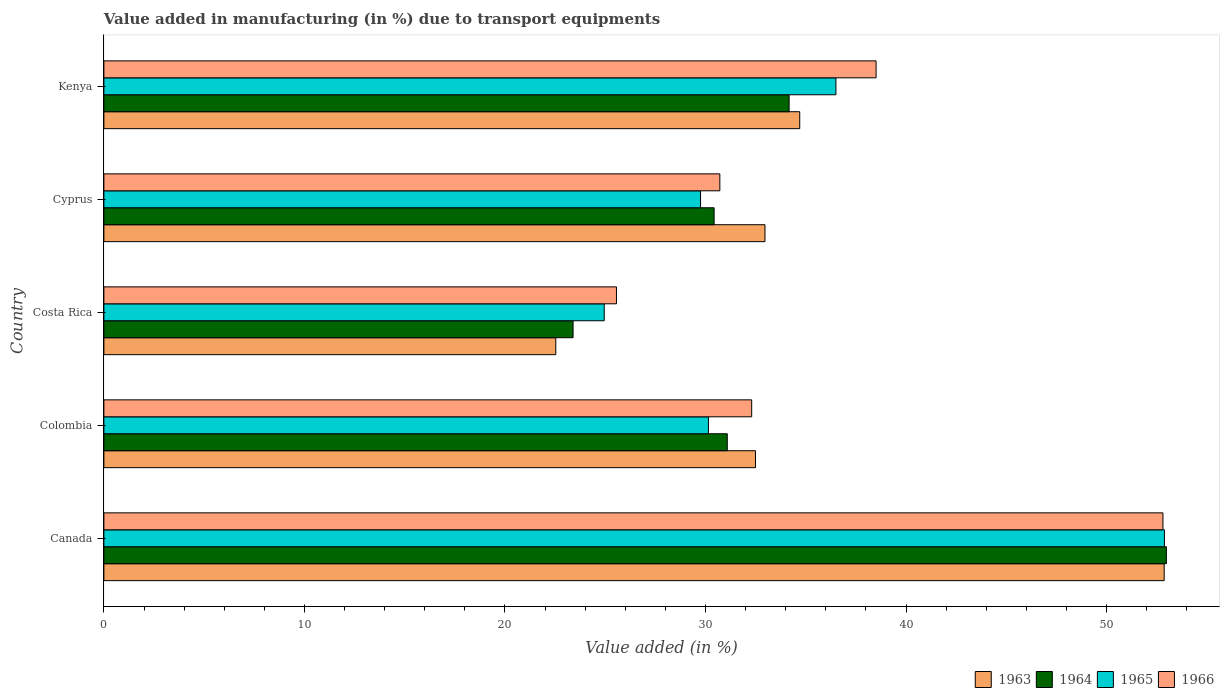How many groups of bars are there?
Your answer should be very brief. 5. What is the percentage of value added in manufacturing due to transport equipments in 1966 in Colombia?
Your response must be concise. 32.3. Across all countries, what is the maximum percentage of value added in manufacturing due to transport equipments in 1963?
Your answer should be compact. 52.87. Across all countries, what is the minimum percentage of value added in manufacturing due to transport equipments in 1963?
Give a very brief answer. 22.53. In which country was the percentage of value added in manufacturing due to transport equipments in 1964 minimum?
Your answer should be compact. Costa Rica. What is the total percentage of value added in manufacturing due to transport equipments in 1963 in the graph?
Provide a succinct answer. 175.57. What is the difference between the percentage of value added in manufacturing due to transport equipments in 1965 in Colombia and that in Cyprus?
Keep it short and to the point. 0.39. What is the difference between the percentage of value added in manufacturing due to transport equipments in 1963 in Cyprus and the percentage of value added in manufacturing due to transport equipments in 1965 in Costa Rica?
Make the answer very short. 8.02. What is the average percentage of value added in manufacturing due to transport equipments in 1966 per country?
Give a very brief answer. 35.98. What is the difference between the percentage of value added in manufacturing due to transport equipments in 1964 and percentage of value added in manufacturing due to transport equipments in 1965 in Costa Rica?
Ensure brevity in your answer.  -1.55. In how many countries, is the percentage of value added in manufacturing due to transport equipments in 1965 greater than 12 %?
Ensure brevity in your answer.  5. What is the ratio of the percentage of value added in manufacturing due to transport equipments in 1964 in Canada to that in Costa Rica?
Keep it short and to the point. 2.26. Is the percentage of value added in manufacturing due to transport equipments in 1966 in Canada less than that in Colombia?
Provide a short and direct response. No. Is the difference between the percentage of value added in manufacturing due to transport equipments in 1964 in Costa Rica and Kenya greater than the difference between the percentage of value added in manufacturing due to transport equipments in 1965 in Costa Rica and Kenya?
Your answer should be compact. Yes. What is the difference between the highest and the second highest percentage of value added in manufacturing due to transport equipments in 1966?
Ensure brevity in your answer.  14.3. What is the difference between the highest and the lowest percentage of value added in manufacturing due to transport equipments in 1966?
Ensure brevity in your answer.  27.25. Is it the case that in every country, the sum of the percentage of value added in manufacturing due to transport equipments in 1965 and percentage of value added in manufacturing due to transport equipments in 1964 is greater than the sum of percentage of value added in manufacturing due to transport equipments in 1966 and percentage of value added in manufacturing due to transport equipments in 1963?
Provide a succinct answer. No. Is it the case that in every country, the sum of the percentage of value added in manufacturing due to transport equipments in 1966 and percentage of value added in manufacturing due to transport equipments in 1965 is greater than the percentage of value added in manufacturing due to transport equipments in 1964?
Ensure brevity in your answer.  Yes. Are all the bars in the graph horizontal?
Ensure brevity in your answer.  Yes. What is the difference between two consecutive major ticks on the X-axis?
Provide a short and direct response. 10. Are the values on the major ticks of X-axis written in scientific E-notation?
Keep it short and to the point. No. Does the graph contain any zero values?
Offer a terse response. No. Where does the legend appear in the graph?
Provide a succinct answer. Bottom right. How many legend labels are there?
Make the answer very short. 4. How are the legend labels stacked?
Keep it short and to the point. Horizontal. What is the title of the graph?
Your answer should be compact. Value added in manufacturing (in %) due to transport equipments. Does "1987" appear as one of the legend labels in the graph?
Provide a short and direct response. No. What is the label or title of the X-axis?
Your answer should be very brief. Value added (in %). What is the label or title of the Y-axis?
Provide a short and direct response. Country. What is the Value added (in %) of 1963 in Canada?
Offer a very short reply. 52.87. What is the Value added (in %) in 1964 in Canada?
Provide a short and direct response. 52.98. What is the Value added (in %) of 1965 in Canada?
Make the answer very short. 52.89. What is the Value added (in %) in 1966 in Canada?
Your answer should be compact. 52.81. What is the Value added (in %) of 1963 in Colombia?
Offer a terse response. 32.49. What is the Value added (in %) in 1964 in Colombia?
Your answer should be very brief. 31.09. What is the Value added (in %) in 1965 in Colombia?
Your answer should be very brief. 30.15. What is the Value added (in %) in 1966 in Colombia?
Provide a short and direct response. 32.3. What is the Value added (in %) in 1963 in Costa Rica?
Give a very brief answer. 22.53. What is the Value added (in %) of 1964 in Costa Rica?
Offer a very short reply. 23.4. What is the Value added (in %) in 1965 in Costa Rica?
Your response must be concise. 24.95. What is the Value added (in %) of 1966 in Costa Rica?
Your answer should be very brief. 25.56. What is the Value added (in %) of 1963 in Cyprus?
Ensure brevity in your answer.  32.97. What is the Value added (in %) in 1964 in Cyprus?
Offer a very short reply. 30.43. What is the Value added (in %) in 1965 in Cyprus?
Offer a terse response. 29.75. What is the Value added (in %) in 1966 in Cyprus?
Your response must be concise. 30.72. What is the Value added (in %) of 1963 in Kenya?
Your answer should be very brief. 34.7. What is the Value added (in %) of 1964 in Kenya?
Your answer should be very brief. 34.17. What is the Value added (in %) in 1965 in Kenya?
Your answer should be very brief. 36.5. What is the Value added (in %) in 1966 in Kenya?
Your answer should be very brief. 38.51. Across all countries, what is the maximum Value added (in %) of 1963?
Offer a very short reply. 52.87. Across all countries, what is the maximum Value added (in %) in 1964?
Provide a short and direct response. 52.98. Across all countries, what is the maximum Value added (in %) in 1965?
Offer a very short reply. 52.89. Across all countries, what is the maximum Value added (in %) of 1966?
Ensure brevity in your answer.  52.81. Across all countries, what is the minimum Value added (in %) of 1963?
Make the answer very short. 22.53. Across all countries, what is the minimum Value added (in %) of 1964?
Offer a terse response. 23.4. Across all countries, what is the minimum Value added (in %) of 1965?
Offer a very short reply. 24.95. Across all countries, what is the minimum Value added (in %) in 1966?
Keep it short and to the point. 25.56. What is the total Value added (in %) of 1963 in the graph?
Ensure brevity in your answer.  175.57. What is the total Value added (in %) of 1964 in the graph?
Keep it short and to the point. 172.06. What is the total Value added (in %) in 1965 in the graph?
Offer a very short reply. 174.24. What is the total Value added (in %) in 1966 in the graph?
Ensure brevity in your answer.  179.9. What is the difference between the Value added (in %) of 1963 in Canada and that in Colombia?
Give a very brief answer. 20.38. What is the difference between the Value added (in %) in 1964 in Canada and that in Colombia?
Keep it short and to the point. 21.9. What is the difference between the Value added (in %) in 1965 in Canada and that in Colombia?
Your answer should be very brief. 22.74. What is the difference between the Value added (in %) of 1966 in Canada and that in Colombia?
Your response must be concise. 20.51. What is the difference between the Value added (in %) in 1963 in Canada and that in Costa Rica?
Keep it short and to the point. 30.34. What is the difference between the Value added (in %) in 1964 in Canada and that in Costa Rica?
Keep it short and to the point. 29.59. What is the difference between the Value added (in %) of 1965 in Canada and that in Costa Rica?
Provide a succinct answer. 27.93. What is the difference between the Value added (in %) of 1966 in Canada and that in Costa Rica?
Your answer should be compact. 27.25. What is the difference between the Value added (in %) of 1963 in Canada and that in Cyprus?
Offer a terse response. 19.91. What is the difference between the Value added (in %) in 1964 in Canada and that in Cyprus?
Offer a terse response. 22.55. What is the difference between the Value added (in %) in 1965 in Canada and that in Cyprus?
Keep it short and to the point. 23.13. What is the difference between the Value added (in %) in 1966 in Canada and that in Cyprus?
Provide a short and direct response. 22.1. What is the difference between the Value added (in %) in 1963 in Canada and that in Kenya?
Offer a terse response. 18.17. What is the difference between the Value added (in %) in 1964 in Canada and that in Kenya?
Give a very brief answer. 18.81. What is the difference between the Value added (in %) of 1965 in Canada and that in Kenya?
Keep it short and to the point. 16.38. What is the difference between the Value added (in %) of 1966 in Canada and that in Kenya?
Ensure brevity in your answer.  14.3. What is the difference between the Value added (in %) in 1963 in Colombia and that in Costa Rica?
Make the answer very short. 9.96. What is the difference between the Value added (in %) in 1964 in Colombia and that in Costa Rica?
Keep it short and to the point. 7.69. What is the difference between the Value added (in %) in 1965 in Colombia and that in Costa Rica?
Your answer should be compact. 5.2. What is the difference between the Value added (in %) in 1966 in Colombia and that in Costa Rica?
Your answer should be compact. 6.74. What is the difference between the Value added (in %) in 1963 in Colombia and that in Cyprus?
Provide a short and direct response. -0.47. What is the difference between the Value added (in %) in 1964 in Colombia and that in Cyprus?
Ensure brevity in your answer.  0.66. What is the difference between the Value added (in %) of 1965 in Colombia and that in Cyprus?
Your answer should be compact. 0.39. What is the difference between the Value added (in %) in 1966 in Colombia and that in Cyprus?
Ensure brevity in your answer.  1.59. What is the difference between the Value added (in %) of 1963 in Colombia and that in Kenya?
Make the answer very short. -2.21. What is the difference between the Value added (in %) of 1964 in Colombia and that in Kenya?
Your answer should be very brief. -3.08. What is the difference between the Value added (in %) of 1965 in Colombia and that in Kenya?
Make the answer very short. -6.36. What is the difference between the Value added (in %) in 1966 in Colombia and that in Kenya?
Provide a short and direct response. -6.2. What is the difference between the Value added (in %) in 1963 in Costa Rica and that in Cyprus?
Your answer should be compact. -10.43. What is the difference between the Value added (in %) in 1964 in Costa Rica and that in Cyprus?
Your answer should be compact. -7.03. What is the difference between the Value added (in %) of 1965 in Costa Rica and that in Cyprus?
Your answer should be very brief. -4.8. What is the difference between the Value added (in %) in 1966 in Costa Rica and that in Cyprus?
Give a very brief answer. -5.16. What is the difference between the Value added (in %) in 1963 in Costa Rica and that in Kenya?
Ensure brevity in your answer.  -12.17. What is the difference between the Value added (in %) in 1964 in Costa Rica and that in Kenya?
Provide a succinct answer. -10.77. What is the difference between the Value added (in %) of 1965 in Costa Rica and that in Kenya?
Make the answer very short. -11.55. What is the difference between the Value added (in %) in 1966 in Costa Rica and that in Kenya?
Keep it short and to the point. -12.95. What is the difference between the Value added (in %) in 1963 in Cyprus and that in Kenya?
Offer a very short reply. -1.73. What is the difference between the Value added (in %) in 1964 in Cyprus and that in Kenya?
Keep it short and to the point. -3.74. What is the difference between the Value added (in %) of 1965 in Cyprus and that in Kenya?
Your answer should be compact. -6.75. What is the difference between the Value added (in %) in 1966 in Cyprus and that in Kenya?
Give a very brief answer. -7.79. What is the difference between the Value added (in %) of 1963 in Canada and the Value added (in %) of 1964 in Colombia?
Offer a very short reply. 21.79. What is the difference between the Value added (in %) in 1963 in Canada and the Value added (in %) in 1965 in Colombia?
Offer a terse response. 22.73. What is the difference between the Value added (in %) of 1963 in Canada and the Value added (in %) of 1966 in Colombia?
Offer a terse response. 20.57. What is the difference between the Value added (in %) of 1964 in Canada and the Value added (in %) of 1965 in Colombia?
Make the answer very short. 22.84. What is the difference between the Value added (in %) of 1964 in Canada and the Value added (in %) of 1966 in Colombia?
Provide a succinct answer. 20.68. What is the difference between the Value added (in %) of 1965 in Canada and the Value added (in %) of 1966 in Colombia?
Your answer should be very brief. 20.58. What is the difference between the Value added (in %) of 1963 in Canada and the Value added (in %) of 1964 in Costa Rica?
Your answer should be very brief. 29.48. What is the difference between the Value added (in %) of 1963 in Canada and the Value added (in %) of 1965 in Costa Rica?
Your answer should be very brief. 27.92. What is the difference between the Value added (in %) of 1963 in Canada and the Value added (in %) of 1966 in Costa Rica?
Keep it short and to the point. 27.31. What is the difference between the Value added (in %) of 1964 in Canada and the Value added (in %) of 1965 in Costa Rica?
Provide a succinct answer. 28.03. What is the difference between the Value added (in %) in 1964 in Canada and the Value added (in %) in 1966 in Costa Rica?
Make the answer very short. 27.42. What is the difference between the Value added (in %) of 1965 in Canada and the Value added (in %) of 1966 in Costa Rica?
Provide a succinct answer. 27.33. What is the difference between the Value added (in %) in 1963 in Canada and the Value added (in %) in 1964 in Cyprus?
Give a very brief answer. 22.44. What is the difference between the Value added (in %) of 1963 in Canada and the Value added (in %) of 1965 in Cyprus?
Your response must be concise. 23.12. What is the difference between the Value added (in %) of 1963 in Canada and the Value added (in %) of 1966 in Cyprus?
Your answer should be compact. 22.16. What is the difference between the Value added (in %) in 1964 in Canada and the Value added (in %) in 1965 in Cyprus?
Your answer should be compact. 23.23. What is the difference between the Value added (in %) in 1964 in Canada and the Value added (in %) in 1966 in Cyprus?
Your answer should be very brief. 22.27. What is the difference between the Value added (in %) of 1965 in Canada and the Value added (in %) of 1966 in Cyprus?
Your answer should be very brief. 22.17. What is the difference between the Value added (in %) in 1963 in Canada and the Value added (in %) in 1964 in Kenya?
Provide a succinct answer. 18.7. What is the difference between the Value added (in %) in 1963 in Canada and the Value added (in %) in 1965 in Kenya?
Keep it short and to the point. 16.37. What is the difference between the Value added (in %) of 1963 in Canada and the Value added (in %) of 1966 in Kenya?
Give a very brief answer. 14.37. What is the difference between the Value added (in %) of 1964 in Canada and the Value added (in %) of 1965 in Kenya?
Offer a very short reply. 16.48. What is the difference between the Value added (in %) in 1964 in Canada and the Value added (in %) in 1966 in Kenya?
Give a very brief answer. 14.47. What is the difference between the Value added (in %) of 1965 in Canada and the Value added (in %) of 1966 in Kenya?
Ensure brevity in your answer.  14.38. What is the difference between the Value added (in %) in 1963 in Colombia and the Value added (in %) in 1964 in Costa Rica?
Keep it short and to the point. 9.1. What is the difference between the Value added (in %) in 1963 in Colombia and the Value added (in %) in 1965 in Costa Rica?
Make the answer very short. 7.54. What is the difference between the Value added (in %) of 1963 in Colombia and the Value added (in %) of 1966 in Costa Rica?
Your answer should be very brief. 6.93. What is the difference between the Value added (in %) in 1964 in Colombia and the Value added (in %) in 1965 in Costa Rica?
Offer a very short reply. 6.14. What is the difference between the Value added (in %) in 1964 in Colombia and the Value added (in %) in 1966 in Costa Rica?
Your response must be concise. 5.53. What is the difference between the Value added (in %) of 1965 in Colombia and the Value added (in %) of 1966 in Costa Rica?
Make the answer very short. 4.59. What is the difference between the Value added (in %) of 1963 in Colombia and the Value added (in %) of 1964 in Cyprus?
Make the answer very short. 2.06. What is the difference between the Value added (in %) of 1963 in Colombia and the Value added (in %) of 1965 in Cyprus?
Offer a very short reply. 2.74. What is the difference between the Value added (in %) of 1963 in Colombia and the Value added (in %) of 1966 in Cyprus?
Provide a short and direct response. 1.78. What is the difference between the Value added (in %) of 1964 in Colombia and the Value added (in %) of 1965 in Cyprus?
Keep it short and to the point. 1.33. What is the difference between the Value added (in %) of 1964 in Colombia and the Value added (in %) of 1966 in Cyprus?
Your answer should be compact. 0.37. What is the difference between the Value added (in %) in 1965 in Colombia and the Value added (in %) in 1966 in Cyprus?
Provide a succinct answer. -0.57. What is the difference between the Value added (in %) in 1963 in Colombia and the Value added (in %) in 1964 in Kenya?
Your answer should be very brief. -1.68. What is the difference between the Value added (in %) of 1963 in Colombia and the Value added (in %) of 1965 in Kenya?
Offer a very short reply. -4.01. What is the difference between the Value added (in %) in 1963 in Colombia and the Value added (in %) in 1966 in Kenya?
Make the answer very short. -6.01. What is the difference between the Value added (in %) of 1964 in Colombia and the Value added (in %) of 1965 in Kenya?
Offer a very short reply. -5.42. What is the difference between the Value added (in %) in 1964 in Colombia and the Value added (in %) in 1966 in Kenya?
Keep it short and to the point. -7.42. What is the difference between the Value added (in %) of 1965 in Colombia and the Value added (in %) of 1966 in Kenya?
Provide a succinct answer. -8.36. What is the difference between the Value added (in %) in 1963 in Costa Rica and the Value added (in %) in 1964 in Cyprus?
Provide a short and direct response. -7.9. What is the difference between the Value added (in %) of 1963 in Costa Rica and the Value added (in %) of 1965 in Cyprus?
Give a very brief answer. -7.22. What is the difference between the Value added (in %) of 1963 in Costa Rica and the Value added (in %) of 1966 in Cyprus?
Provide a short and direct response. -8.18. What is the difference between the Value added (in %) in 1964 in Costa Rica and the Value added (in %) in 1965 in Cyprus?
Keep it short and to the point. -6.36. What is the difference between the Value added (in %) in 1964 in Costa Rica and the Value added (in %) in 1966 in Cyprus?
Keep it short and to the point. -7.32. What is the difference between the Value added (in %) of 1965 in Costa Rica and the Value added (in %) of 1966 in Cyprus?
Your answer should be compact. -5.77. What is the difference between the Value added (in %) in 1963 in Costa Rica and the Value added (in %) in 1964 in Kenya?
Provide a succinct answer. -11.64. What is the difference between the Value added (in %) in 1963 in Costa Rica and the Value added (in %) in 1965 in Kenya?
Make the answer very short. -13.97. What is the difference between the Value added (in %) in 1963 in Costa Rica and the Value added (in %) in 1966 in Kenya?
Give a very brief answer. -15.97. What is the difference between the Value added (in %) of 1964 in Costa Rica and the Value added (in %) of 1965 in Kenya?
Your response must be concise. -13.11. What is the difference between the Value added (in %) of 1964 in Costa Rica and the Value added (in %) of 1966 in Kenya?
Provide a succinct answer. -15.11. What is the difference between the Value added (in %) of 1965 in Costa Rica and the Value added (in %) of 1966 in Kenya?
Your answer should be compact. -13.56. What is the difference between the Value added (in %) of 1963 in Cyprus and the Value added (in %) of 1964 in Kenya?
Offer a very short reply. -1.2. What is the difference between the Value added (in %) of 1963 in Cyprus and the Value added (in %) of 1965 in Kenya?
Make the answer very short. -3.54. What is the difference between the Value added (in %) in 1963 in Cyprus and the Value added (in %) in 1966 in Kenya?
Ensure brevity in your answer.  -5.54. What is the difference between the Value added (in %) of 1964 in Cyprus and the Value added (in %) of 1965 in Kenya?
Your answer should be compact. -6.07. What is the difference between the Value added (in %) of 1964 in Cyprus and the Value added (in %) of 1966 in Kenya?
Keep it short and to the point. -8.08. What is the difference between the Value added (in %) in 1965 in Cyprus and the Value added (in %) in 1966 in Kenya?
Keep it short and to the point. -8.75. What is the average Value added (in %) in 1963 per country?
Your response must be concise. 35.11. What is the average Value added (in %) of 1964 per country?
Give a very brief answer. 34.41. What is the average Value added (in %) in 1965 per country?
Offer a very short reply. 34.85. What is the average Value added (in %) of 1966 per country?
Your answer should be very brief. 35.98. What is the difference between the Value added (in %) of 1963 and Value added (in %) of 1964 in Canada?
Make the answer very short. -0.11. What is the difference between the Value added (in %) of 1963 and Value added (in %) of 1965 in Canada?
Give a very brief answer. -0.01. What is the difference between the Value added (in %) of 1963 and Value added (in %) of 1966 in Canada?
Give a very brief answer. 0.06. What is the difference between the Value added (in %) of 1964 and Value added (in %) of 1965 in Canada?
Your answer should be very brief. 0.1. What is the difference between the Value added (in %) of 1964 and Value added (in %) of 1966 in Canada?
Make the answer very short. 0.17. What is the difference between the Value added (in %) of 1965 and Value added (in %) of 1966 in Canada?
Your answer should be very brief. 0.07. What is the difference between the Value added (in %) in 1963 and Value added (in %) in 1964 in Colombia?
Provide a short and direct response. 1.41. What is the difference between the Value added (in %) in 1963 and Value added (in %) in 1965 in Colombia?
Offer a very short reply. 2.35. What is the difference between the Value added (in %) of 1963 and Value added (in %) of 1966 in Colombia?
Offer a very short reply. 0.19. What is the difference between the Value added (in %) of 1964 and Value added (in %) of 1965 in Colombia?
Offer a terse response. 0.94. What is the difference between the Value added (in %) of 1964 and Value added (in %) of 1966 in Colombia?
Offer a very short reply. -1.22. What is the difference between the Value added (in %) in 1965 and Value added (in %) in 1966 in Colombia?
Provide a succinct answer. -2.16. What is the difference between the Value added (in %) of 1963 and Value added (in %) of 1964 in Costa Rica?
Offer a very short reply. -0.86. What is the difference between the Value added (in %) of 1963 and Value added (in %) of 1965 in Costa Rica?
Offer a terse response. -2.42. What is the difference between the Value added (in %) in 1963 and Value added (in %) in 1966 in Costa Rica?
Your answer should be compact. -3.03. What is the difference between the Value added (in %) of 1964 and Value added (in %) of 1965 in Costa Rica?
Your answer should be very brief. -1.55. What is the difference between the Value added (in %) of 1964 and Value added (in %) of 1966 in Costa Rica?
Your answer should be very brief. -2.16. What is the difference between the Value added (in %) of 1965 and Value added (in %) of 1966 in Costa Rica?
Offer a very short reply. -0.61. What is the difference between the Value added (in %) of 1963 and Value added (in %) of 1964 in Cyprus?
Keep it short and to the point. 2.54. What is the difference between the Value added (in %) of 1963 and Value added (in %) of 1965 in Cyprus?
Your response must be concise. 3.21. What is the difference between the Value added (in %) of 1963 and Value added (in %) of 1966 in Cyprus?
Make the answer very short. 2.25. What is the difference between the Value added (in %) in 1964 and Value added (in %) in 1965 in Cyprus?
Give a very brief answer. 0.68. What is the difference between the Value added (in %) in 1964 and Value added (in %) in 1966 in Cyprus?
Your answer should be very brief. -0.29. What is the difference between the Value added (in %) of 1965 and Value added (in %) of 1966 in Cyprus?
Your answer should be very brief. -0.96. What is the difference between the Value added (in %) in 1963 and Value added (in %) in 1964 in Kenya?
Provide a succinct answer. 0.53. What is the difference between the Value added (in %) in 1963 and Value added (in %) in 1965 in Kenya?
Your response must be concise. -1.8. What is the difference between the Value added (in %) of 1963 and Value added (in %) of 1966 in Kenya?
Your answer should be compact. -3.81. What is the difference between the Value added (in %) of 1964 and Value added (in %) of 1965 in Kenya?
Give a very brief answer. -2.33. What is the difference between the Value added (in %) of 1964 and Value added (in %) of 1966 in Kenya?
Provide a succinct answer. -4.34. What is the difference between the Value added (in %) of 1965 and Value added (in %) of 1966 in Kenya?
Your answer should be compact. -2. What is the ratio of the Value added (in %) in 1963 in Canada to that in Colombia?
Ensure brevity in your answer.  1.63. What is the ratio of the Value added (in %) in 1964 in Canada to that in Colombia?
Ensure brevity in your answer.  1.7. What is the ratio of the Value added (in %) in 1965 in Canada to that in Colombia?
Make the answer very short. 1.75. What is the ratio of the Value added (in %) of 1966 in Canada to that in Colombia?
Offer a very short reply. 1.63. What is the ratio of the Value added (in %) in 1963 in Canada to that in Costa Rica?
Your answer should be very brief. 2.35. What is the ratio of the Value added (in %) in 1964 in Canada to that in Costa Rica?
Offer a very short reply. 2.26. What is the ratio of the Value added (in %) in 1965 in Canada to that in Costa Rica?
Offer a very short reply. 2.12. What is the ratio of the Value added (in %) of 1966 in Canada to that in Costa Rica?
Provide a short and direct response. 2.07. What is the ratio of the Value added (in %) of 1963 in Canada to that in Cyprus?
Offer a very short reply. 1.6. What is the ratio of the Value added (in %) in 1964 in Canada to that in Cyprus?
Provide a short and direct response. 1.74. What is the ratio of the Value added (in %) of 1965 in Canada to that in Cyprus?
Offer a terse response. 1.78. What is the ratio of the Value added (in %) of 1966 in Canada to that in Cyprus?
Give a very brief answer. 1.72. What is the ratio of the Value added (in %) in 1963 in Canada to that in Kenya?
Give a very brief answer. 1.52. What is the ratio of the Value added (in %) of 1964 in Canada to that in Kenya?
Offer a very short reply. 1.55. What is the ratio of the Value added (in %) in 1965 in Canada to that in Kenya?
Offer a very short reply. 1.45. What is the ratio of the Value added (in %) in 1966 in Canada to that in Kenya?
Your response must be concise. 1.37. What is the ratio of the Value added (in %) of 1963 in Colombia to that in Costa Rica?
Provide a succinct answer. 1.44. What is the ratio of the Value added (in %) in 1964 in Colombia to that in Costa Rica?
Keep it short and to the point. 1.33. What is the ratio of the Value added (in %) of 1965 in Colombia to that in Costa Rica?
Your answer should be very brief. 1.21. What is the ratio of the Value added (in %) of 1966 in Colombia to that in Costa Rica?
Your answer should be compact. 1.26. What is the ratio of the Value added (in %) in 1963 in Colombia to that in Cyprus?
Offer a very short reply. 0.99. What is the ratio of the Value added (in %) in 1964 in Colombia to that in Cyprus?
Make the answer very short. 1.02. What is the ratio of the Value added (in %) in 1965 in Colombia to that in Cyprus?
Keep it short and to the point. 1.01. What is the ratio of the Value added (in %) of 1966 in Colombia to that in Cyprus?
Your response must be concise. 1.05. What is the ratio of the Value added (in %) of 1963 in Colombia to that in Kenya?
Provide a succinct answer. 0.94. What is the ratio of the Value added (in %) in 1964 in Colombia to that in Kenya?
Ensure brevity in your answer.  0.91. What is the ratio of the Value added (in %) in 1965 in Colombia to that in Kenya?
Provide a short and direct response. 0.83. What is the ratio of the Value added (in %) of 1966 in Colombia to that in Kenya?
Make the answer very short. 0.84. What is the ratio of the Value added (in %) of 1963 in Costa Rica to that in Cyprus?
Your answer should be compact. 0.68. What is the ratio of the Value added (in %) of 1964 in Costa Rica to that in Cyprus?
Make the answer very short. 0.77. What is the ratio of the Value added (in %) in 1965 in Costa Rica to that in Cyprus?
Make the answer very short. 0.84. What is the ratio of the Value added (in %) of 1966 in Costa Rica to that in Cyprus?
Make the answer very short. 0.83. What is the ratio of the Value added (in %) in 1963 in Costa Rica to that in Kenya?
Offer a very short reply. 0.65. What is the ratio of the Value added (in %) of 1964 in Costa Rica to that in Kenya?
Your response must be concise. 0.68. What is the ratio of the Value added (in %) in 1965 in Costa Rica to that in Kenya?
Provide a short and direct response. 0.68. What is the ratio of the Value added (in %) in 1966 in Costa Rica to that in Kenya?
Give a very brief answer. 0.66. What is the ratio of the Value added (in %) in 1963 in Cyprus to that in Kenya?
Give a very brief answer. 0.95. What is the ratio of the Value added (in %) in 1964 in Cyprus to that in Kenya?
Offer a very short reply. 0.89. What is the ratio of the Value added (in %) of 1965 in Cyprus to that in Kenya?
Your answer should be very brief. 0.82. What is the ratio of the Value added (in %) of 1966 in Cyprus to that in Kenya?
Your answer should be very brief. 0.8. What is the difference between the highest and the second highest Value added (in %) of 1963?
Your answer should be compact. 18.17. What is the difference between the highest and the second highest Value added (in %) of 1964?
Your answer should be compact. 18.81. What is the difference between the highest and the second highest Value added (in %) of 1965?
Your answer should be very brief. 16.38. What is the difference between the highest and the second highest Value added (in %) in 1966?
Your answer should be very brief. 14.3. What is the difference between the highest and the lowest Value added (in %) in 1963?
Your answer should be compact. 30.34. What is the difference between the highest and the lowest Value added (in %) of 1964?
Offer a very short reply. 29.59. What is the difference between the highest and the lowest Value added (in %) in 1965?
Provide a succinct answer. 27.93. What is the difference between the highest and the lowest Value added (in %) of 1966?
Make the answer very short. 27.25. 